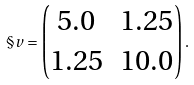Convert formula to latex. <formula><loc_0><loc_0><loc_500><loc_500>\S v = \left ( \begin{matrix} 5 . 0 & 1 . 2 5 \\ 1 . 2 5 & 1 0 . 0 \end{matrix} \right ) .</formula> 